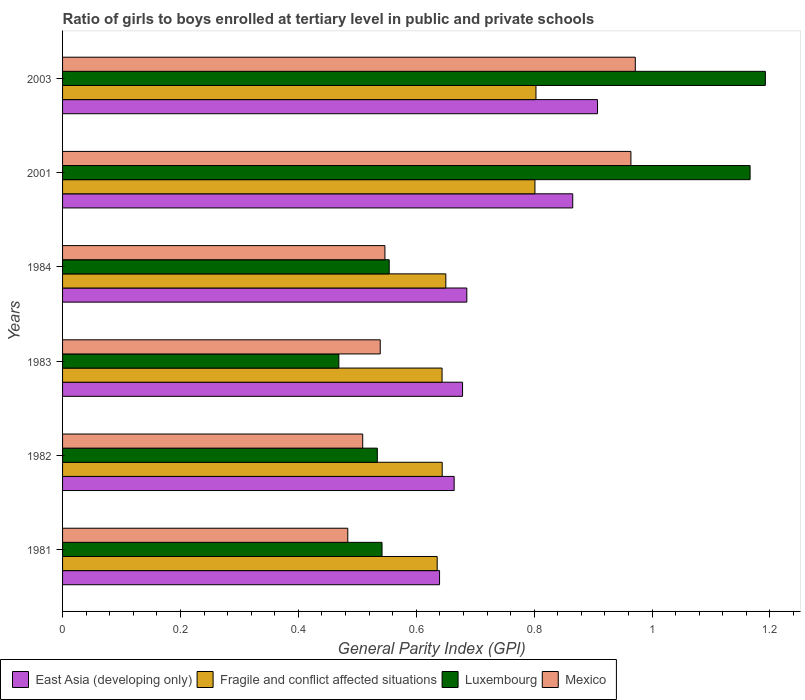How many different coloured bars are there?
Your response must be concise. 4. How many groups of bars are there?
Keep it short and to the point. 6. Are the number of bars per tick equal to the number of legend labels?
Offer a very short reply. Yes. Are the number of bars on each tick of the Y-axis equal?
Make the answer very short. Yes. How many bars are there on the 1st tick from the top?
Keep it short and to the point. 4. What is the label of the 1st group of bars from the top?
Keep it short and to the point. 2003. In how many cases, is the number of bars for a given year not equal to the number of legend labels?
Give a very brief answer. 0. What is the general parity index in Fragile and conflict affected situations in 1981?
Your answer should be compact. 0.64. Across all years, what is the maximum general parity index in Luxembourg?
Your answer should be very brief. 1.19. Across all years, what is the minimum general parity index in Luxembourg?
Your answer should be very brief. 0.47. In which year was the general parity index in East Asia (developing only) maximum?
Offer a terse response. 2003. What is the total general parity index in Fragile and conflict affected situations in the graph?
Offer a terse response. 4.18. What is the difference between the general parity index in East Asia (developing only) in 1982 and that in 1983?
Your response must be concise. -0.01. What is the difference between the general parity index in Luxembourg in 1981 and the general parity index in Fragile and conflict affected situations in 1984?
Ensure brevity in your answer.  -0.11. What is the average general parity index in East Asia (developing only) per year?
Keep it short and to the point. 0.74. In the year 1983, what is the difference between the general parity index in Luxembourg and general parity index in Fragile and conflict affected situations?
Keep it short and to the point. -0.18. In how many years, is the general parity index in East Asia (developing only) greater than 0.6400000000000001 ?
Keep it short and to the point. 5. What is the ratio of the general parity index in East Asia (developing only) in 1981 to that in 1982?
Offer a terse response. 0.96. What is the difference between the highest and the second highest general parity index in Luxembourg?
Your answer should be very brief. 0.03. What is the difference between the highest and the lowest general parity index in Fragile and conflict affected situations?
Provide a short and direct response. 0.17. In how many years, is the general parity index in Mexico greater than the average general parity index in Mexico taken over all years?
Provide a short and direct response. 2. Is the sum of the general parity index in Fragile and conflict affected situations in 1982 and 2003 greater than the maximum general parity index in Mexico across all years?
Give a very brief answer. Yes. Is it the case that in every year, the sum of the general parity index in East Asia (developing only) and general parity index in Mexico is greater than the sum of general parity index in Luxembourg and general parity index in Fragile and conflict affected situations?
Ensure brevity in your answer.  No. What does the 3rd bar from the top in 2003 represents?
Your answer should be compact. Fragile and conflict affected situations. What does the 1st bar from the bottom in 1982 represents?
Offer a terse response. East Asia (developing only). Is it the case that in every year, the sum of the general parity index in Fragile and conflict affected situations and general parity index in East Asia (developing only) is greater than the general parity index in Luxembourg?
Ensure brevity in your answer.  Yes. What is the difference between two consecutive major ticks on the X-axis?
Provide a succinct answer. 0.2. How are the legend labels stacked?
Make the answer very short. Horizontal. What is the title of the graph?
Offer a terse response. Ratio of girls to boys enrolled at tertiary level in public and private schools. Does "Small states" appear as one of the legend labels in the graph?
Your response must be concise. No. What is the label or title of the X-axis?
Ensure brevity in your answer.  General Parity Index (GPI). What is the General Parity Index (GPI) in East Asia (developing only) in 1981?
Keep it short and to the point. 0.64. What is the General Parity Index (GPI) of Fragile and conflict affected situations in 1981?
Offer a very short reply. 0.64. What is the General Parity Index (GPI) of Luxembourg in 1981?
Provide a short and direct response. 0.54. What is the General Parity Index (GPI) in Mexico in 1981?
Your answer should be very brief. 0.48. What is the General Parity Index (GPI) of East Asia (developing only) in 1982?
Ensure brevity in your answer.  0.66. What is the General Parity Index (GPI) of Fragile and conflict affected situations in 1982?
Your answer should be compact. 0.64. What is the General Parity Index (GPI) in Luxembourg in 1982?
Provide a succinct answer. 0.53. What is the General Parity Index (GPI) of Mexico in 1982?
Provide a short and direct response. 0.51. What is the General Parity Index (GPI) in East Asia (developing only) in 1983?
Keep it short and to the point. 0.68. What is the General Parity Index (GPI) in Fragile and conflict affected situations in 1983?
Provide a short and direct response. 0.64. What is the General Parity Index (GPI) of Luxembourg in 1983?
Provide a succinct answer. 0.47. What is the General Parity Index (GPI) of Mexico in 1983?
Give a very brief answer. 0.54. What is the General Parity Index (GPI) of East Asia (developing only) in 1984?
Keep it short and to the point. 0.69. What is the General Parity Index (GPI) of Fragile and conflict affected situations in 1984?
Keep it short and to the point. 0.65. What is the General Parity Index (GPI) of Luxembourg in 1984?
Your response must be concise. 0.55. What is the General Parity Index (GPI) of Mexico in 1984?
Your answer should be compact. 0.55. What is the General Parity Index (GPI) of East Asia (developing only) in 2001?
Your answer should be very brief. 0.87. What is the General Parity Index (GPI) of Fragile and conflict affected situations in 2001?
Your answer should be compact. 0.8. What is the General Parity Index (GPI) of Luxembourg in 2001?
Give a very brief answer. 1.17. What is the General Parity Index (GPI) of Mexico in 2001?
Ensure brevity in your answer.  0.96. What is the General Parity Index (GPI) in East Asia (developing only) in 2003?
Offer a terse response. 0.91. What is the General Parity Index (GPI) of Fragile and conflict affected situations in 2003?
Your response must be concise. 0.8. What is the General Parity Index (GPI) in Luxembourg in 2003?
Your answer should be compact. 1.19. What is the General Parity Index (GPI) of Mexico in 2003?
Provide a succinct answer. 0.97. Across all years, what is the maximum General Parity Index (GPI) in East Asia (developing only)?
Make the answer very short. 0.91. Across all years, what is the maximum General Parity Index (GPI) of Fragile and conflict affected situations?
Your answer should be compact. 0.8. Across all years, what is the maximum General Parity Index (GPI) of Luxembourg?
Offer a terse response. 1.19. Across all years, what is the maximum General Parity Index (GPI) of Mexico?
Your response must be concise. 0.97. Across all years, what is the minimum General Parity Index (GPI) in East Asia (developing only)?
Your answer should be compact. 0.64. Across all years, what is the minimum General Parity Index (GPI) of Fragile and conflict affected situations?
Your response must be concise. 0.64. Across all years, what is the minimum General Parity Index (GPI) in Luxembourg?
Offer a very short reply. 0.47. Across all years, what is the minimum General Parity Index (GPI) of Mexico?
Your answer should be very brief. 0.48. What is the total General Parity Index (GPI) in East Asia (developing only) in the graph?
Keep it short and to the point. 4.44. What is the total General Parity Index (GPI) of Fragile and conflict affected situations in the graph?
Provide a short and direct response. 4.18. What is the total General Parity Index (GPI) of Luxembourg in the graph?
Provide a succinct answer. 4.46. What is the total General Parity Index (GPI) of Mexico in the graph?
Your answer should be very brief. 4.01. What is the difference between the General Parity Index (GPI) of East Asia (developing only) in 1981 and that in 1982?
Make the answer very short. -0.02. What is the difference between the General Parity Index (GPI) in Fragile and conflict affected situations in 1981 and that in 1982?
Your answer should be very brief. -0.01. What is the difference between the General Parity Index (GPI) in Luxembourg in 1981 and that in 1982?
Give a very brief answer. 0.01. What is the difference between the General Parity Index (GPI) in Mexico in 1981 and that in 1982?
Your response must be concise. -0.03. What is the difference between the General Parity Index (GPI) in East Asia (developing only) in 1981 and that in 1983?
Offer a very short reply. -0.04. What is the difference between the General Parity Index (GPI) of Fragile and conflict affected situations in 1981 and that in 1983?
Provide a succinct answer. -0.01. What is the difference between the General Parity Index (GPI) of Luxembourg in 1981 and that in 1983?
Give a very brief answer. 0.07. What is the difference between the General Parity Index (GPI) in Mexico in 1981 and that in 1983?
Ensure brevity in your answer.  -0.06. What is the difference between the General Parity Index (GPI) in East Asia (developing only) in 1981 and that in 1984?
Offer a very short reply. -0.05. What is the difference between the General Parity Index (GPI) of Fragile and conflict affected situations in 1981 and that in 1984?
Your answer should be very brief. -0.01. What is the difference between the General Parity Index (GPI) in Luxembourg in 1981 and that in 1984?
Your response must be concise. -0.01. What is the difference between the General Parity Index (GPI) in Mexico in 1981 and that in 1984?
Offer a very short reply. -0.06. What is the difference between the General Parity Index (GPI) of East Asia (developing only) in 1981 and that in 2001?
Your answer should be compact. -0.23. What is the difference between the General Parity Index (GPI) of Fragile and conflict affected situations in 1981 and that in 2001?
Offer a terse response. -0.17. What is the difference between the General Parity Index (GPI) of Luxembourg in 1981 and that in 2001?
Ensure brevity in your answer.  -0.62. What is the difference between the General Parity Index (GPI) of Mexico in 1981 and that in 2001?
Provide a short and direct response. -0.48. What is the difference between the General Parity Index (GPI) of East Asia (developing only) in 1981 and that in 2003?
Keep it short and to the point. -0.27. What is the difference between the General Parity Index (GPI) in Fragile and conflict affected situations in 1981 and that in 2003?
Ensure brevity in your answer.  -0.17. What is the difference between the General Parity Index (GPI) of Luxembourg in 1981 and that in 2003?
Give a very brief answer. -0.65. What is the difference between the General Parity Index (GPI) in Mexico in 1981 and that in 2003?
Provide a short and direct response. -0.49. What is the difference between the General Parity Index (GPI) in East Asia (developing only) in 1982 and that in 1983?
Your answer should be very brief. -0.01. What is the difference between the General Parity Index (GPI) of Fragile and conflict affected situations in 1982 and that in 1983?
Give a very brief answer. 0. What is the difference between the General Parity Index (GPI) in Luxembourg in 1982 and that in 1983?
Offer a terse response. 0.07. What is the difference between the General Parity Index (GPI) in Mexico in 1982 and that in 1983?
Your answer should be very brief. -0.03. What is the difference between the General Parity Index (GPI) in East Asia (developing only) in 1982 and that in 1984?
Offer a terse response. -0.02. What is the difference between the General Parity Index (GPI) of Fragile and conflict affected situations in 1982 and that in 1984?
Your answer should be very brief. -0.01. What is the difference between the General Parity Index (GPI) in Luxembourg in 1982 and that in 1984?
Offer a very short reply. -0.02. What is the difference between the General Parity Index (GPI) of Mexico in 1982 and that in 1984?
Make the answer very short. -0.04. What is the difference between the General Parity Index (GPI) in East Asia (developing only) in 1982 and that in 2001?
Your answer should be very brief. -0.2. What is the difference between the General Parity Index (GPI) in Fragile and conflict affected situations in 1982 and that in 2001?
Your answer should be very brief. -0.16. What is the difference between the General Parity Index (GPI) in Luxembourg in 1982 and that in 2001?
Keep it short and to the point. -0.63. What is the difference between the General Parity Index (GPI) in Mexico in 1982 and that in 2001?
Your answer should be very brief. -0.46. What is the difference between the General Parity Index (GPI) of East Asia (developing only) in 1982 and that in 2003?
Make the answer very short. -0.24. What is the difference between the General Parity Index (GPI) of Fragile and conflict affected situations in 1982 and that in 2003?
Keep it short and to the point. -0.16. What is the difference between the General Parity Index (GPI) of Luxembourg in 1982 and that in 2003?
Provide a short and direct response. -0.66. What is the difference between the General Parity Index (GPI) in Mexico in 1982 and that in 2003?
Offer a very short reply. -0.46. What is the difference between the General Parity Index (GPI) in East Asia (developing only) in 1983 and that in 1984?
Offer a very short reply. -0.01. What is the difference between the General Parity Index (GPI) of Fragile and conflict affected situations in 1983 and that in 1984?
Ensure brevity in your answer.  -0.01. What is the difference between the General Parity Index (GPI) of Luxembourg in 1983 and that in 1984?
Provide a succinct answer. -0.09. What is the difference between the General Parity Index (GPI) in Mexico in 1983 and that in 1984?
Give a very brief answer. -0.01. What is the difference between the General Parity Index (GPI) of East Asia (developing only) in 1983 and that in 2001?
Your response must be concise. -0.19. What is the difference between the General Parity Index (GPI) of Fragile and conflict affected situations in 1983 and that in 2001?
Ensure brevity in your answer.  -0.16. What is the difference between the General Parity Index (GPI) of Luxembourg in 1983 and that in 2001?
Give a very brief answer. -0.7. What is the difference between the General Parity Index (GPI) of Mexico in 1983 and that in 2001?
Offer a terse response. -0.43. What is the difference between the General Parity Index (GPI) of East Asia (developing only) in 1983 and that in 2003?
Keep it short and to the point. -0.23. What is the difference between the General Parity Index (GPI) in Fragile and conflict affected situations in 1983 and that in 2003?
Offer a terse response. -0.16. What is the difference between the General Parity Index (GPI) in Luxembourg in 1983 and that in 2003?
Make the answer very short. -0.72. What is the difference between the General Parity Index (GPI) of Mexico in 1983 and that in 2003?
Provide a succinct answer. -0.43. What is the difference between the General Parity Index (GPI) of East Asia (developing only) in 1984 and that in 2001?
Offer a very short reply. -0.18. What is the difference between the General Parity Index (GPI) of Fragile and conflict affected situations in 1984 and that in 2001?
Offer a terse response. -0.15. What is the difference between the General Parity Index (GPI) in Luxembourg in 1984 and that in 2001?
Give a very brief answer. -0.61. What is the difference between the General Parity Index (GPI) in Mexico in 1984 and that in 2001?
Offer a very short reply. -0.42. What is the difference between the General Parity Index (GPI) of East Asia (developing only) in 1984 and that in 2003?
Keep it short and to the point. -0.22. What is the difference between the General Parity Index (GPI) of Fragile and conflict affected situations in 1984 and that in 2003?
Your response must be concise. -0.15. What is the difference between the General Parity Index (GPI) in Luxembourg in 1984 and that in 2003?
Provide a short and direct response. -0.64. What is the difference between the General Parity Index (GPI) of Mexico in 1984 and that in 2003?
Keep it short and to the point. -0.42. What is the difference between the General Parity Index (GPI) of East Asia (developing only) in 2001 and that in 2003?
Keep it short and to the point. -0.04. What is the difference between the General Parity Index (GPI) in Fragile and conflict affected situations in 2001 and that in 2003?
Provide a succinct answer. -0. What is the difference between the General Parity Index (GPI) of Luxembourg in 2001 and that in 2003?
Provide a short and direct response. -0.03. What is the difference between the General Parity Index (GPI) of Mexico in 2001 and that in 2003?
Your answer should be compact. -0.01. What is the difference between the General Parity Index (GPI) in East Asia (developing only) in 1981 and the General Parity Index (GPI) in Fragile and conflict affected situations in 1982?
Offer a terse response. -0. What is the difference between the General Parity Index (GPI) of East Asia (developing only) in 1981 and the General Parity Index (GPI) of Luxembourg in 1982?
Offer a terse response. 0.11. What is the difference between the General Parity Index (GPI) of East Asia (developing only) in 1981 and the General Parity Index (GPI) of Mexico in 1982?
Your response must be concise. 0.13. What is the difference between the General Parity Index (GPI) of Fragile and conflict affected situations in 1981 and the General Parity Index (GPI) of Luxembourg in 1982?
Offer a terse response. 0.1. What is the difference between the General Parity Index (GPI) of Fragile and conflict affected situations in 1981 and the General Parity Index (GPI) of Mexico in 1982?
Your response must be concise. 0.13. What is the difference between the General Parity Index (GPI) in Luxembourg in 1981 and the General Parity Index (GPI) in Mexico in 1982?
Offer a very short reply. 0.03. What is the difference between the General Parity Index (GPI) in East Asia (developing only) in 1981 and the General Parity Index (GPI) in Fragile and conflict affected situations in 1983?
Provide a short and direct response. -0. What is the difference between the General Parity Index (GPI) in East Asia (developing only) in 1981 and the General Parity Index (GPI) in Luxembourg in 1983?
Your answer should be very brief. 0.17. What is the difference between the General Parity Index (GPI) of East Asia (developing only) in 1981 and the General Parity Index (GPI) of Mexico in 1983?
Your response must be concise. 0.1. What is the difference between the General Parity Index (GPI) in Fragile and conflict affected situations in 1981 and the General Parity Index (GPI) in Luxembourg in 1983?
Ensure brevity in your answer.  0.17. What is the difference between the General Parity Index (GPI) of Fragile and conflict affected situations in 1981 and the General Parity Index (GPI) of Mexico in 1983?
Provide a short and direct response. 0.1. What is the difference between the General Parity Index (GPI) of Luxembourg in 1981 and the General Parity Index (GPI) of Mexico in 1983?
Keep it short and to the point. 0. What is the difference between the General Parity Index (GPI) of East Asia (developing only) in 1981 and the General Parity Index (GPI) of Fragile and conflict affected situations in 1984?
Offer a very short reply. -0.01. What is the difference between the General Parity Index (GPI) in East Asia (developing only) in 1981 and the General Parity Index (GPI) in Luxembourg in 1984?
Your answer should be very brief. 0.09. What is the difference between the General Parity Index (GPI) in East Asia (developing only) in 1981 and the General Parity Index (GPI) in Mexico in 1984?
Your response must be concise. 0.09. What is the difference between the General Parity Index (GPI) of Fragile and conflict affected situations in 1981 and the General Parity Index (GPI) of Luxembourg in 1984?
Your answer should be compact. 0.08. What is the difference between the General Parity Index (GPI) of Fragile and conflict affected situations in 1981 and the General Parity Index (GPI) of Mexico in 1984?
Your answer should be very brief. 0.09. What is the difference between the General Parity Index (GPI) of Luxembourg in 1981 and the General Parity Index (GPI) of Mexico in 1984?
Offer a terse response. -0. What is the difference between the General Parity Index (GPI) in East Asia (developing only) in 1981 and the General Parity Index (GPI) in Fragile and conflict affected situations in 2001?
Offer a terse response. -0.16. What is the difference between the General Parity Index (GPI) of East Asia (developing only) in 1981 and the General Parity Index (GPI) of Luxembourg in 2001?
Give a very brief answer. -0.53. What is the difference between the General Parity Index (GPI) of East Asia (developing only) in 1981 and the General Parity Index (GPI) of Mexico in 2001?
Ensure brevity in your answer.  -0.32. What is the difference between the General Parity Index (GPI) of Fragile and conflict affected situations in 1981 and the General Parity Index (GPI) of Luxembourg in 2001?
Give a very brief answer. -0.53. What is the difference between the General Parity Index (GPI) of Fragile and conflict affected situations in 1981 and the General Parity Index (GPI) of Mexico in 2001?
Ensure brevity in your answer.  -0.33. What is the difference between the General Parity Index (GPI) of Luxembourg in 1981 and the General Parity Index (GPI) of Mexico in 2001?
Make the answer very short. -0.42. What is the difference between the General Parity Index (GPI) in East Asia (developing only) in 1981 and the General Parity Index (GPI) in Fragile and conflict affected situations in 2003?
Offer a terse response. -0.16. What is the difference between the General Parity Index (GPI) in East Asia (developing only) in 1981 and the General Parity Index (GPI) in Luxembourg in 2003?
Your answer should be very brief. -0.55. What is the difference between the General Parity Index (GPI) in East Asia (developing only) in 1981 and the General Parity Index (GPI) in Mexico in 2003?
Your answer should be compact. -0.33. What is the difference between the General Parity Index (GPI) of Fragile and conflict affected situations in 1981 and the General Parity Index (GPI) of Luxembourg in 2003?
Your answer should be compact. -0.56. What is the difference between the General Parity Index (GPI) of Fragile and conflict affected situations in 1981 and the General Parity Index (GPI) of Mexico in 2003?
Provide a short and direct response. -0.34. What is the difference between the General Parity Index (GPI) of Luxembourg in 1981 and the General Parity Index (GPI) of Mexico in 2003?
Keep it short and to the point. -0.43. What is the difference between the General Parity Index (GPI) of East Asia (developing only) in 1982 and the General Parity Index (GPI) of Fragile and conflict affected situations in 1983?
Your answer should be very brief. 0.02. What is the difference between the General Parity Index (GPI) in East Asia (developing only) in 1982 and the General Parity Index (GPI) in Luxembourg in 1983?
Offer a terse response. 0.2. What is the difference between the General Parity Index (GPI) in East Asia (developing only) in 1982 and the General Parity Index (GPI) in Mexico in 1983?
Offer a terse response. 0.13. What is the difference between the General Parity Index (GPI) of Fragile and conflict affected situations in 1982 and the General Parity Index (GPI) of Luxembourg in 1983?
Ensure brevity in your answer.  0.18. What is the difference between the General Parity Index (GPI) in Fragile and conflict affected situations in 1982 and the General Parity Index (GPI) in Mexico in 1983?
Your answer should be compact. 0.11. What is the difference between the General Parity Index (GPI) of Luxembourg in 1982 and the General Parity Index (GPI) of Mexico in 1983?
Keep it short and to the point. -0.01. What is the difference between the General Parity Index (GPI) of East Asia (developing only) in 1982 and the General Parity Index (GPI) of Fragile and conflict affected situations in 1984?
Make the answer very short. 0.01. What is the difference between the General Parity Index (GPI) of East Asia (developing only) in 1982 and the General Parity Index (GPI) of Luxembourg in 1984?
Keep it short and to the point. 0.11. What is the difference between the General Parity Index (GPI) in East Asia (developing only) in 1982 and the General Parity Index (GPI) in Mexico in 1984?
Give a very brief answer. 0.12. What is the difference between the General Parity Index (GPI) in Fragile and conflict affected situations in 1982 and the General Parity Index (GPI) in Luxembourg in 1984?
Keep it short and to the point. 0.09. What is the difference between the General Parity Index (GPI) of Fragile and conflict affected situations in 1982 and the General Parity Index (GPI) of Mexico in 1984?
Make the answer very short. 0.1. What is the difference between the General Parity Index (GPI) in Luxembourg in 1982 and the General Parity Index (GPI) in Mexico in 1984?
Your answer should be compact. -0.01. What is the difference between the General Parity Index (GPI) of East Asia (developing only) in 1982 and the General Parity Index (GPI) of Fragile and conflict affected situations in 2001?
Your answer should be compact. -0.14. What is the difference between the General Parity Index (GPI) in East Asia (developing only) in 1982 and the General Parity Index (GPI) in Luxembourg in 2001?
Your answer should be very brief. -0.5. What is the difference between the General Parity Index (GPI) in East Asia (developing only) in 1982 and the General Parity Index (GPI) in Mexico in 2001?
Ensure brevity in your answer.  -0.3. What is the difference between the General Parity Index (GPI) in Fragile and conflict affected situations in 1982 and the General Parity Index (GPI) in Luxembourg in 2001?
Make the answer very short. -0.52. What is the difference between the General Parity Index (GPI) in Fragile and conflict affected situations in 1982 and the General Parity Index (GPI) in Mexico in 2001?
Offer a terse response. -0.32. What is the difference between the General Parity Index (GPI) in Luxembourg in 1982 and the General Parity Index (GPI) in Mexico in 2001?
Give a very brief answer. -0.43. What is the difference between the General Parity Index (GPI) in East Asia (developing only) in 1982 and the General Parity Index (GPI) in Fragile and conflict affected situations in 2003?
Make the answer very short. -0.14. What is the difference between the General Parity Index (GPI) of East Asia (developing only) in 1982 and the General Parity Index (GPI) of Luxembourg in 2003?
Ensure brevity in your answer.  -0.53. What is the difference between the General Parity Index (GPI) in East Asia (developing only) in 1982 and the General Parity Index (GPI) in Mexico in 2003?
Offer a terse response. -0.31. What is the difference between the General Parity Index (GPI) of Fragile and conflict affected situations in 1982 and the General Parity Index (GPI) of Luxembourg in 2003?
Your answer should be very brief. -0.55. What is the difference between the General Parity Index (GPI) of Fragile and conflict affected situations in 1982 and the General Parity Index (GPI) of Mexico in 2003?
Give a very brief answer. -0.33. What is the difference between the General Parity Index (GPI) in Luxembourg in 1982 and the General Parity Index (GPI) in Mexico in 2003?
Your response must be concise. -0.44. What is the difference between the General Parity Index (GPI) of East Asia (developing only) in 1983 and the General Parity Index (GPI) of Fragile and conflict affected situations in 1984?
Give a very brief answer. 0.03. What is the difference between the General Parity Index (GPI) of East Asia (developing only) in 1983 and the General Parity Index (GPI) of Luxembourg in 1984?
Provide a short and direct response. 0.12. What is the difference between the General Parity Index (GPI) in East Asia (developing only) in 1983 and the General Parity Index (GPI) in Mexico in 1984?
Keep it short and to the point. 0.13. What is the difference between the General Parity Index (GPI) in Fragile and conflict affected situations in 1983 and the General Parity Index (GPI) in Luxembourg in 1984?
Provide a short and direct response. 0.09. What is the difference between the General Parity Index (GPI) in Fragile and conflict affected situations in 1983 and the General Parity Index (GPI) in Mexico in 1984?
Make the answer very short. 0.1. What is the difference between the General Parity Index (GPI) of Luxembourg in 1983 and the General Parity Index (GPI) of Mexico in 1984?
Your answer should be compact. -0.08. What is the difference between the General Parity Index (GPI) in East Asia (developing only) in 1983 and the General Parity Index (GPI) in Fragile and conflict affected situations in 2001?
Ensure brevity in your answer.  -0.12. What is the difference between the General Parity Index (GPI) in East Asia (developing only) in 1983 and the General Parity Index (GPI) in Luxembourg in 2001?
Make the answer very short. -0.49. What is the difference between the General Parity Index (GPI) of East Asia (developing only) in 1983 and the General Parity Index (GPI) of Mexico in 2001?
Offer a very short reply. -0.29. What is the difference between the General Parity Index (GPI) in Fragile and conflict affected situations in 1983 and the General Parity Index (GPI) in Luxembourg in 2001?
Make the answer very short. -0.52. What is the difference between the General Parity Index (GPI) of Fragile and conflict affected situations in 1983 and the General Parity Index (GPI) of Mexico in 2001?
Your answer should be compact. -0.32. What is the difference between the General Parity Index (GPI) in Luxembourg in 1983 and the General Parity Index (GPI) in Mexico in 2001?
Provide a short and direct response. -0.5. What is the difference between the General Parity Index (GPI) in East Asia (developing only) in 1983 and the General Parity Index (GPI) in Fragile and conflict affected situations in 2003?
Your response must be concise. -0.12. What is the difference between the General Parity Index (GPI) in East Asia (developing only) in 1983 and the General Parity Index (GPI) in Luxembourg in 2003?
Ensure brevity in your answer.  -0.51. What is the difference between the General Parity Index (GPI) of East Asia (developing only) in 1983 and the General Parity Index (GPI) of Mexico in 2003?
Offer a terse response. -0.29. What is the difference between the General Parity Index (GPI) of Fragile and conflict affected situations in 1983 and the General Parity Index (GPI) of Luxembourg in 2003?
Make the answer very short. -0.55. What is the difference between the General Parity Index (GPI) of Fragile and conflict affected situations in 1983 and the General Parity Index (GPI) of Mexico in 2003?
Provide a short and direct response. -0.33. What is the difference between the General Parity Index (GPI) of Luxembourg in 1983 and the General Parity Index (GPI) of Mexico in 2003?
Offer a very short reply. -0.5. What is the difference between the General Parity Index (GPI) of East Asia (developing only) in 1984 and the General Parity Index (GPI) of Fragile and conflict affected situations in 2001?
Provide a succinct answer. -0.12. What is the difference between the General Parity Index (GPI) of East Asia (developing only) in 1984 and the General Parity Index (GPI) of Luxembourg in 2001?
Keep it short and to the point. -0.48. What is the difference between the General Parity Index (GPI) in East Asia (developing only) in 1984 and the General Parity Index (GPI) in Mexico in 2001?
Your answer should be compact. -0.28. What is the difference between the General Parity Index (GPI) of Fragile and conflict affected situations in 1984 and the General Parity Index (GPI) of Luxembourg in 2001?
Keep it short and to the point. -0.52. What is the difference between the General Parity Index (GPI) of Fragile and conflict affected situations in 1984 and the General Parity Index (GPI) of Mexico in 2001?
Keep it short and to the point. -0.31. What is the difference between the General Parity Index (GPI) of Luxembourg in 1984 and the General Parity Index (GPI) of Mexico in 2001?
Your answer should be compact. -0.41. What is the difference between the General Parity Index (GPI) in East Asia (developing only) in 1984 and the General Parity Index (GPI) in Fragile and conflict affected situations in 2003?
Your answer should be compact. -0.12. What is the difference between the General Parity Index (GPI) of East Asia (developing only) in 1984 and the General Parity Index (GPI) of Luxembourg in 2003?
Make the answer very short. -0.51. What is the difference between the General Parity Index (GPI) in East Asia (developing only) in 1984 and the General Parity Index (GPI) in Mexico in 2003?
Ensure brevity in your answer.  -0.29. What is the difference between the General Parity Index (GPI) of Fragile and conflict affected situations in 1984 and the General Parity Index (GPI) of Luxembourg in 2003?
Keep it short and to the point. -0.54. What is the difference between the General Parity Index (GPI) in Fragile and conflict affected situations in 1984 and the General Parity Index (GPI) in Mexico in 2003?
Offer a very short reply. -0.32. What is the difference between the General Parity Index (GPI) in Luxembourg in 1984 and the General Parity Index (GPI) in Mexico in 2003?
Make the answer very short. -0.42. What is the difference between the General Parity Index (GPI) in East Asia (developing only) in 2001 and the General Parity Index (GPI) in Fragile and conflict affected situations in 2003?
Give a very brief answer. 0.06. What is the difference between the General Parity Index (GPI) in East Asia (developing only) in 2001 and the General Parity Index (GPI) in Luxembourg in 2003?
Keep it short and to the point. -0.33. What is the difference between the General Parity Index (GPI) in East Asia (developing only) in 2001 and the General Parity Index (GPI) in Mexico in 2003?
Offer a terse response. -0.11. What is the difference between the General Parity Index (GPI) of Fragile and conflict affected situations in 2001 and the General Parity Index (GPI) of Luxembourg in 2003?
Provide a short and direct response. -0.39. What is the difference between the General Parity Index (GPI) of Fragile and conflict affected situations in 2001 and the General Parity Index (GPI) of Mexico in 2003?
Provide a succinct answer. -0.17. What is the difference between the General Parity Index (GPI) in Luxembourg in 2001 and the General Parity Index (GPI) in Mexico in 2003?
Keep it short and to the point. 0.19. What is the average General Parity Index (GPI) of East Asia (developing only) per year?
Your answer should be very brief. 0.74. What is the average General Parity Index (GPI) in Fragile and conflict affected situations per year?
Keep it short and to the point. 0.7. What is the average General Parity Index (GPI) in Luxembourg per year?
Make the answer very short. 0.74. What is the average General Parity Index (GPI) of Mexico per year?
Offer a terse response. 0.67. In the year 1981, what is the difference between the General Parity Index (GPI) in East Asia (developing only) and General Parity Index (GPI) in Fragile and conflict affected situations?
Provide a short and direct response. 0. In the year 1981, what is the difference between the General Parity Index (GPI) in East Asia (developing only) and General Parity Index (GPI) in Luxembourg?
Give a very brief answer. 0.1. In the year 1981, what is the difference between the General Parity Index (GPI) in East Asia (developing only) and General Parity Index (GPI) in Mexico?
Provide a succinct answer. 0.16. In the year 1981, what is the difference between the General Parity Index (GPI) of Fragile and conflict affected situations and General Parity Index (GPI) of Luxembourg?
Your response must be concise. 0.09. In the year 1981, what is the difference between the General Parity Index (GPI) in Fragile and conflict affected situations and General Parity Index (GPI) in Mexico?
Offer a terse response. 0.15. In the year 1981, what is the difference between the General Parity Index (GPI) in Luxembourg and General Parity Index (GPI) in Mexico?
Offer a very short reply. 0.06. In the year 1982, what is the difference between the General Parity Index (GPI) in East Asia (developing only) and General Parity Index (GPI) in Fragile and conflict affected situations?
Your answer should be compact. 0.02. In the year 1982, what is the difference between the General Parity Index (GPI) of East Asia (developing only) and General Parity Index (GPI) of Luxembourg?
Make the answer very short. 0.13. In the year 1982, what is the difference between the General Parity Index (GPI) of East Asia (developing only) and General Parity Index (GPI) of Mexico?
Your answer should be very brief. 0.16. In the year 1982, what is the difference between the General Parity Index (GPI) in Fragile and conflict affected situations and General Parity Index (GPI) in Luxembourg?
Give a very brief answer. 0.11. In the year 1982, what is the difference between the General Parity Index (GPI) in Fragile and conflict affected situations and General Parity Index (GPI) in Mexico?
Make the answer very short. 0.13. In the year 1982, what is the difference between the General Parity Index (GPI) of Luxembourg and General Parity Index (GPI) of Mexico?
Keep it short and to the point. 0.02. In the year 1983, what is the difference between the General Parity Index (GPI) in East Asia (developing only) and General Parity Index (GPI) in Fragile and conflict affected situations?
Offer a very short reply. 0.03. In the year 1983, what is the difference between the General Parity Index (GPI) of East Asia (developing only) and General Parity Index (GPI) of Luxembourg?
Offer a terse response. 0.21. In the year 1983, what is the difference between the General Parity Index (GPI) of East Asia (developing only) and General Parity Index (GPI) of Mexico?
Offer a very short reply. 0.14. In the year 1983, what is the difference between the General Parity Index (GPI) of Fragile and conflict affected situations and General Parity Index (GPI) of Luxembourg?
Provide a succinct answer. 0.18. In the year 1983, what is the difference between the General Parity Index (GPI) in Fragile and conflict affected situations and General Parity Index (GPI) in Mexico?
Provide a short and direct response. 0.1. In the year 1983, what is the difference between the General Parity Index (GPI) in Luxembourg and General Parity Index (GPI) in Mexico?
Make the answer very short. -0.07. In the year 1984, what is the difference between the General Parity Index (GPI) in East Asia (developing only) and General Parity Index (GPI) in Fragile and conflict affected situations?
Provide a succinct answer. 0.04. In the year 1984, what is the difference between the General Parity Index (GPI) in East Asia (developing only) and General Parity Index (GPI) in Luxembourg?
Give a very brief answer. 0.13. In the year 1984, what is the difference between the General Parity Index (GPI) of East Asia (developing only) and General Parity Index (GPI) of Mexico?
Make the answer very short. 0.14. In the year 1984, what is the difference between the General Parity Index (GPI) of Fragile and conflict affected situations and General Parity Index (GPI) of Luxembourg?
Your answer should be compact. 0.1. In the year 1984, what is the difference between the General Parity Index (GPI) in Fragile and conflict affected situations and General Parity Index (GPI) in Mexico?
Keep it short and to the point. 0.1. In the year 1984, what is the difference between the General Parity Index (GPI) in Luxembourg and General Parity Index (GPI) in Mexico?
Ensure brevity in your answer.  0.01. In the year 2001, what is the difference between the General Parity Index (GPI) in East Asia (developing only) and General Parity Index (GPI) in Fragile and conflict affected situations?
Make the answer very short. 0.06. In the year 2001, what is the difference between the General Parity Index (GPI) of East Asia (developing only) and General Parity Index (GPI) of Luxembourg?
Make the answer very short. -0.3. In the year 2001, what is the difference between the General Parity Index (GPI) of East Asia (developing only) and General Parity Index (GPI) of Mexico?
Give a very brief answer. -0.1. In the year 2001, what is the difference between the General Parity Index (GPI) of Fragile and conflict affected situations and General Parity Index (GPI) of Luxembourg?
Ensure brevity in your answer.  -0.36. In the year 2001, what is the difference between the General Parity Index (GPI) in Fragile and conflict affected situations and General Parity Index (GPI) in Mexico?
Provide a succinct answer. -0.16. In the year 2001, what is the difference between the General Parity Index (GPI) in Luxembourg and General Parity Index (GPI) in Mexico?
Your response must be concise. 0.2. In the year 2003, what is the difference between the General Parity Index (GPI) of East Asia (developing only) and General Parity Index (GPI) of Fragile and conflict affected situations?
Offer a very short reply. 0.1. In the year 2003, what is the difference between the General Parity Index (GPI) in East Asia (developing only) and General Parity Index (GPI) in Luxembourg?
Make the answer very short. -0.28. In the year 2003, what is the difference between the General Parity Index (GPI) of East Asia (developing only) and General Parity Index (GPI) of Mexico?
Ensure brevity in your answer.  -0.06. In the year 2003, what is the difference between the General Parity Index (GPI) of Fragile and conflict affected situations and General Parity Index (GPI) of Luxembourg?
Give a very brief answer. -0.39. In the year 2003, what is the difference between the General Parity Index (GPI) in Fragile and conflict affected situations and General Parity Index (GPI) in Mexico?
Provide a succinct answer. -0.17. In the year 2003, what is the difference between the General Parity Index (GPI) in Luxembourg and General Parity Index (GPI) in Mexico?
Provide a succinct answer. 0.22. What is the ratio of the General Parity Index (GPI) of East Asia (developing only) in 1981 to that in 1982?
Provide a succinct answer. 0.96. What is the ratio of the General Parity Index (GPI) of Fragile and conflict affected situations in 1981 to that in 1982?
Your answer should be compact. 0.99. What is the ratio of the General Parity Index (GPI) in Luxembourg in 1981 to that in 1982?
Your answer should be very brief. 1.01. What is the ratio of the General Parity Index (GPI) in Mexico in 1981 to that in 1982?
Your response must be concise. 0.95. What is the ratio of the General Parity Index (GPI) of East Asia (developing only) in 1981 to that in 1983?
Your answer should be very brief. 0.94. What is the ratio of the General Parity Index (GPI) of Fragile and conflict affected situations in 1981 to that in 1983?
Offer a terse response. 0.99. What is the ratio of the General Parity Index (GPI) in Luxembourg in 1981 to that in 1983?
Provide a succinct answer. 1.16. What is the ratio of the General Parity Index (GPI) of Mexico in 1981 to that in 1983?
Offer a terse response. 0.9. What is the ratio of the General Parity Index (GPI) in East Asia (developing only) in 1981 to that in 1984?
Your response must be concise. 0.93. What is the ratio of the General Parity Index (GPI) of Fragile and conflict affected situations in 1981 to that in 1984?
Provide a succinct answer. 0.98. What is the ratio of the General Parity Index (GPI) of Luxembourg in 1981 to that in 1984?
Provide a short and direct response. 0.98. What is the ratio of the General Parity Index (GPI) of Mexico in 1981 to that in 1984?
Your answer should be very brief. 0.88. What is the ratio of the General Parity Index (GPI) of East Asia (developing only) in 1981 to that in 2001?
Make the answer very short. 0.74. What is the ratio of the General Parity Index (GPI) in Fragile and conflict affected situations in 1981 to that in 2001?
Offer a very short reply. 0.79. What is the ratio of the General Parity Index (GPI) in Luxembourg in 1981 to that in 2001?
Your answer should be compact. 0.46. What is the ratio of the General Parity Index (GPI) in Mexico in 1981 to that in 2001?
Give a very brief answer. 0.5. What is the ratio of the General Parity Index (GPI) of East Asia (developing only) in 1981 to that in 2003?
Your answer should be compact. 0.7. What is the ratio of the General Parity Index (GPI) in Fragile and conflict affected situations in 1981 to that in 2003?
Your response must be concise. 0.79. What is the ratio of the General Parity Index (GPI) of Luxembourg in 1981 to that in 2003?
Your response must be concise. 0.45. What is the ratio of the General Parity Index (GPI) of Mexico in 1981 to that in 2003?
Provide a succinct answer. 0.5. What is the ratio of the General Parity Index (GPI) of East Asia (developing only) in 1982 to that in 1983?
Your answer should be very brief. 0.98. What is the ratio of the General Parity Index (GPI) of Luxembourg in 1982 to that in 1983?
Ensure brevity in your answer.  1.14. What is the ratio of the General Parity Index (GPI) of Mexico in 1982 to that in 1983?
Make the answer very short. 0.94. What is the ratio of the General Parity Index (GPI) of East Asia (developing only) in 1982 to that in 1984?
Your answer should be compact. 0.97. What is the ratio of the General Parity Index (GPI) in Luxembourg in 1982 to that in 1984?
Provide a short and direct response. 0.96. What is the ratio of the General Parity Index (GPI) in Mexico in 1982 to that in 1984?
Your answer should be very brief. 0.93. What is the ratio of the General Parity Index (GPI) of East Asia (developing only) in 1982 to that in 2001?
Give a very brief answer. 0.77. What is the ratio of the General Parity Index (GPI) of Fragile and conflict affected situations in 1982 to that in 2001?
Offer a very short reply. 0.8. What is the ratio of the General Parity Index (GPI) in Luxembourg in 1982 to that in 2001?
Offer a terse response. 0.46. What is the ratio of the General Parity Index (GPI) in Mexico in 1982 to that in 2001?
Your response must be concise. 0.53. What is the ratio of the General Parity Index (GPI) in East Asia (developing only) in 1982 to that in 2003?
Ensure brevity in your answer.  0.73. What is the ratio of the General Parity Index (GPI) of Fragile and conflict affected situations in 1982 to that in 2003?
Make the answer very short. 0.8. What is the ratio of the General Parity Index (GPI) in Luxembourg in 1982 to that in 2003?
Your response must be concise. 0.45. What is the ratio of the General Parity Index (GPI) of Mexico in 1982 to that in 2003?
Provide a short and direct response. 0.52. What is the ratio of the General Parity Index (GPI) of East Asia (developing only) in 1983 to that in 1984?
Make the answer very short. 0.99. What is the ratio of the General Parity Index (GPI) in Fragile and conflict affected situations in 1983 to that in 1984?
Provide a succinct answer. 0.99. What is the ratio of the General Parity Index (GPI) in Luxembourg in 1983 to that in 1984?
Your answer should be very brief. 0.85. What is the ratio of the General Parity Index (GPI) of Mexico in 1983 to that in 1984?
Keep it short and to the point. 0.99. What is the ratio of the General Parity Index (GPI) in East Asia (developing only) in 1983 to that in 2001?
Offer a very short reply. 0.78. What is the ratio of the General Parity Index (GPI) of Fragile and conflict affected situations in 1983 to that in 2001?
Offer a terse response. 0.8. What is the ratio of the General Parity Index (GPI) of Luxembourg in 1983 to that in 2001?
Give a very brief answer. 0.4. What is the ratio of the General Parity Index (GPI) of Mexico in 1983 to that in 2001?
Ensure brevity in your answer.  0.56. What is the ratio of the General Parity Index (GPI) of East Asia (developing only) in 1983 to that in 2003?
Give a very brief answer. 0.75. What is the ratio of the General Parity Index (GPI) of Fragile and conflict affected situations in 1983 to that in 2003?
Ensure brevity in your answer.  0.8. What is the ratio of the General Parity Index (GPI) of Luxembourg in 1983 to that in 2003?
Provide a succinct answer. 0.39. What is the ratio of the General Parity Index (GPI) of Mexico in 1983 to that in 2003?
Keep it short and to the point. 0.55. What is the ratio of the General Parity Index (GPI) of East Asia (developing only) in 1984 to that in 2001?
Keep it short and to the point. 0.79. What is the ratio of the General Parity Index (GPI) in Fragile and conflict affected situations in 1984 to that in 2001?
Make the answer very short. 0.81. What is the ratio of the General Parity Index (GPI) in Luxembourg in 1984 to that in 2001?
Your answer should be very brief. 0.48. What is the ratio of the General Parity Index (GPI) in Mexico in 1984 to that in 2001?
Provide a succinct answer. 0.57. What is the ratio of the General Parity Index (GPI) of East Asia (developing only) in 1984 to that in 2003?
Ensure brevity in your answer.  0.76. What is the ratio of the General Parity Index (GPI) in Fragile and conflict affected situations in 1984 to that in 2003?
Ensure brevity in your answer.  0.81. What is the ratio of the General Parity Index (GPI) in Luxembourg in 1984 to that in 2003?
Ensure brevity in your answer.  0.46. What is the ratio of the General Parity Index (GPI) of Mexico in 1984 to that in 2003?
Your answer should be compact. 0.56. What is the ratio of the General Parity Index (GPI) in East Asia (developing only) in 2001 to that in 2003?
Offer a terse response. 0.95. What is the ratio of the General Parity Index (GPI) of Luxembourg in 2001 to that in 2003?
Offer a terse response. 0.98. What is the difference between the highest and the second highest General Parity Index (GPI) of East Asia (developing only)?
Provide a succinct answer. 0.04. What is the difference between the highest and the second highest General Parity Index (GPI) of Fragile and conflict affected situations?
Make the answer very short. 0. What is the difference between the highest and the second highest General Parity Index (GPI) of Luxembourg?
Give a very brief answer. 0.03. What is the difference between the highest and the second highest General Parity Index (GPI) in Mexico?
Provide a succinct answer. 0.01. What is the difference between the highest and the lowest General Parity Index (GPI) in East Asia (developing only)?
Ensure brevity in your answer.  0.27. What is the difference between the highest and the lowest General Parity Index (GPI) in Fragile and conflict affected situations?
Your answer should be very brief. 0.17. What is the difference between the highest and the lowest General Parity Index (GPI) of Luxembourg?
Ensure brevity in your answer.  0.72. What is the difference between the highest and the lowest General Parity Index (GPI) in Mexico?
Offer a very short reply. 0.49. 